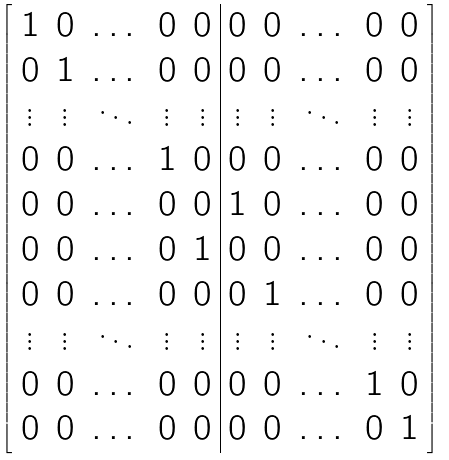Convert formula to latex. <formula><loc_0><loc_0><loc_500><loc_500>\left [ \begin{array} { c c c c c | c c c c c } 1 & 0 & \dots & 0 & 0 & 0 & 0 & \dots & 0 & 0 \\ 0 & 1 & \dots & 0 & 0 & 0 & 0 & \dots & 0 & 0 \\ \vdots & \vdots & \ddots & \vdots & \vdots & \vdots & \vdots & \ddots & \vdots & \vdots \\ 0 & 0 & \dots & 1 & 0 & 0 & 0 & \dots & 0 & 0 \\ 0 & 0 & \dots & 0 & 0 & 1 & 0 & \dots & 0 & 0 \\ 0 & 0 & \dots & 0 & 1 & 0 & 0 & \dots & 0 & 0 \\ 0 & 0 & \dots & 0 & 0 & 0 & 1 & \dots & 0 & 0 \\ \vdots & \vdots & \ddots & \vdots & \vdots & \vdots & \vdots & \ddots & \vdots & \vdots \\ 0 & 0 & \dots & 0 & 0 & 0 & 0 & \dots & 1 & 0 \\ 0 & 0 & \dots & 0 & 0 & 0 & 0 & \dots & 0 & 1 \\ \end{array} \right ]</formula> 